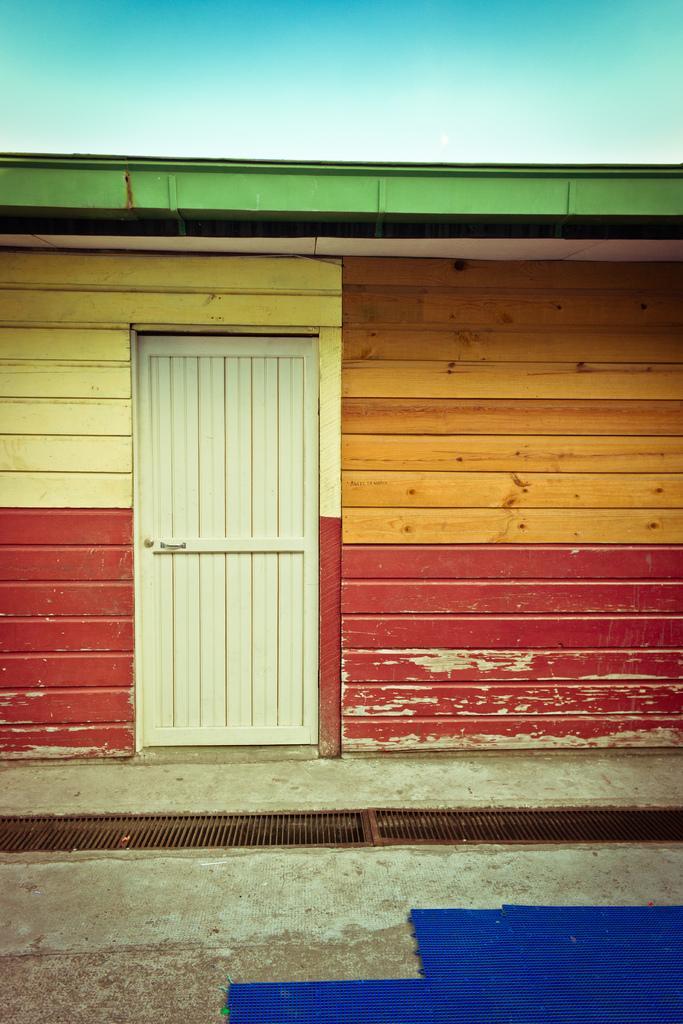Please provide a concise description of this image. This picture is clicked outside. In the foreground there are some blue color objects placed on the ground and we can see the metal rods and a door of a shed. In the background we can see the sky. 